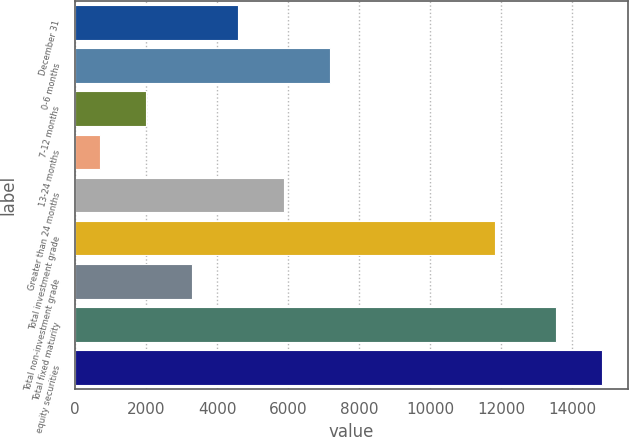<chart> <loc_0><loc_0><loc_500><loc_500><bar_chart><fcel>December 31<fcel>0-6 months<fcel>7-12 months<fcel>13-24 months<fcel>Greater than 24 months<fcel>Total investment grade<fcel>Total non-investment grade<fcel>Total fixed maturity<fcel>equity securities<nl><fcel>4573.8<fcel>7163<fcel>1984.6<fcel>690<fcel>5868.4<fcel>11826<fcel>3279.2<fcel>13534<fcel>14828.6<nl></chart> 